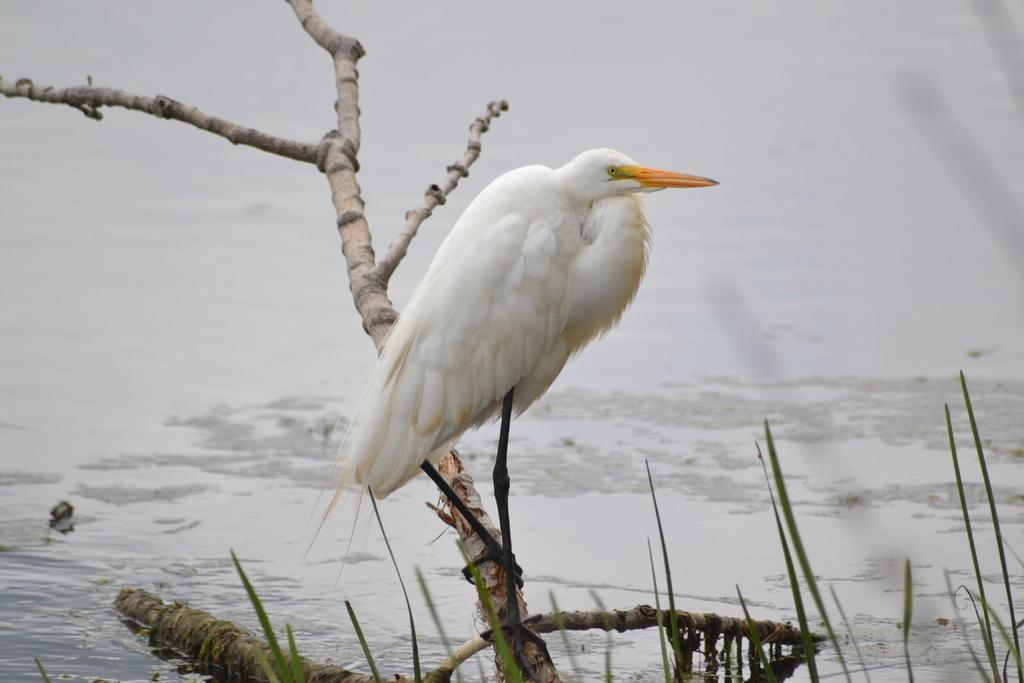What is the main subject of the image? There is a crane in the image. Where is the crane located? The crane is sitting on a branch. What type of tree does the branch belong to? The branch is from a dry tree. What is the weather like in the image? There is snow and water in the image, suggesting a cold and possibly wet environment. Can you hear the crane laughing in the image? There is no sound in the image, so it is impossible to hear the crane laughing. Additionally, cranes do not laugh like humans. 